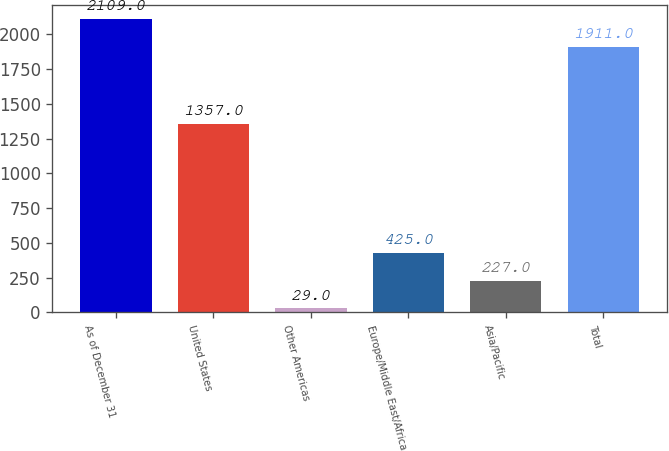Convert chart to OTSL. <chart><loc_0><loc_0><loc_500><loc_500><bar_chart><fcel>As of December 31<fcel>United States<fcel>Other Americas<fcel>Europe/Middle East/Africa<fcel>Asia/Pacific<fcel>Total<nl><fcel>2109<fcel>1357<fcel>29<fcel>425<fcel>227<fcel>1911<nl></chart> 